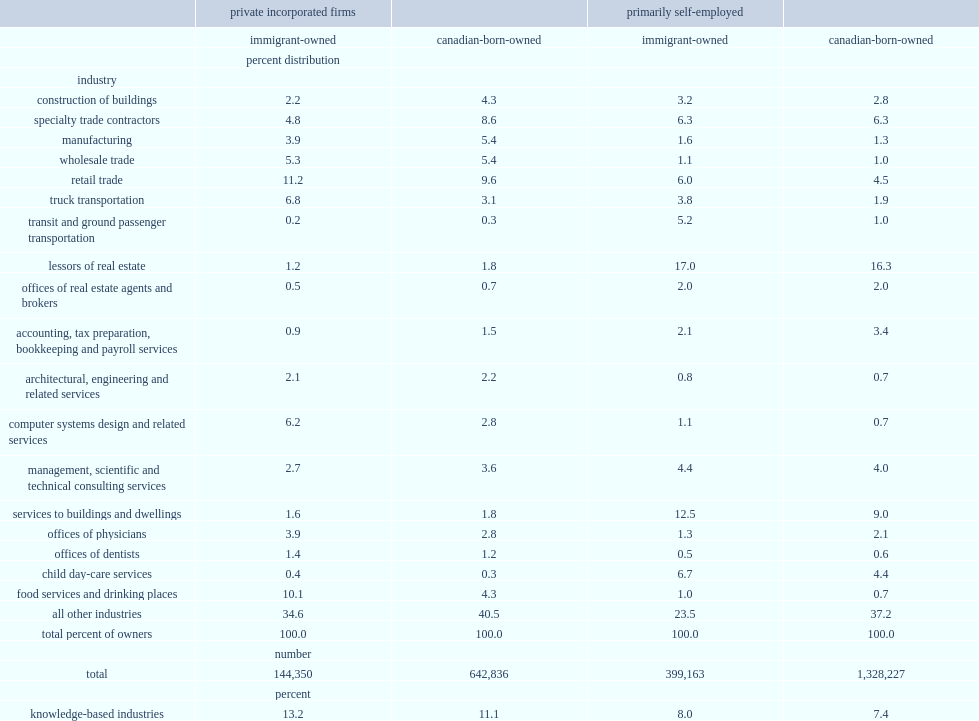How many percent of private incorporated businesses owned by immigrants were located in the kbi sector? 13.2. How many percent of private incorporated businesses owned by the canadian-born were located in the kbi sector. 11.1. Among the primarily self-employed, how many percent of immigrant businesses were in the kbi sector? 8. Among the primarily self-employed, how many percent of canadian-born owned businesses were in the kbi sector? 7.4. Which industry has the largest shares of immigrant- and canadian-owned businesses among the primarily self-employed? Lessors of real estate. 